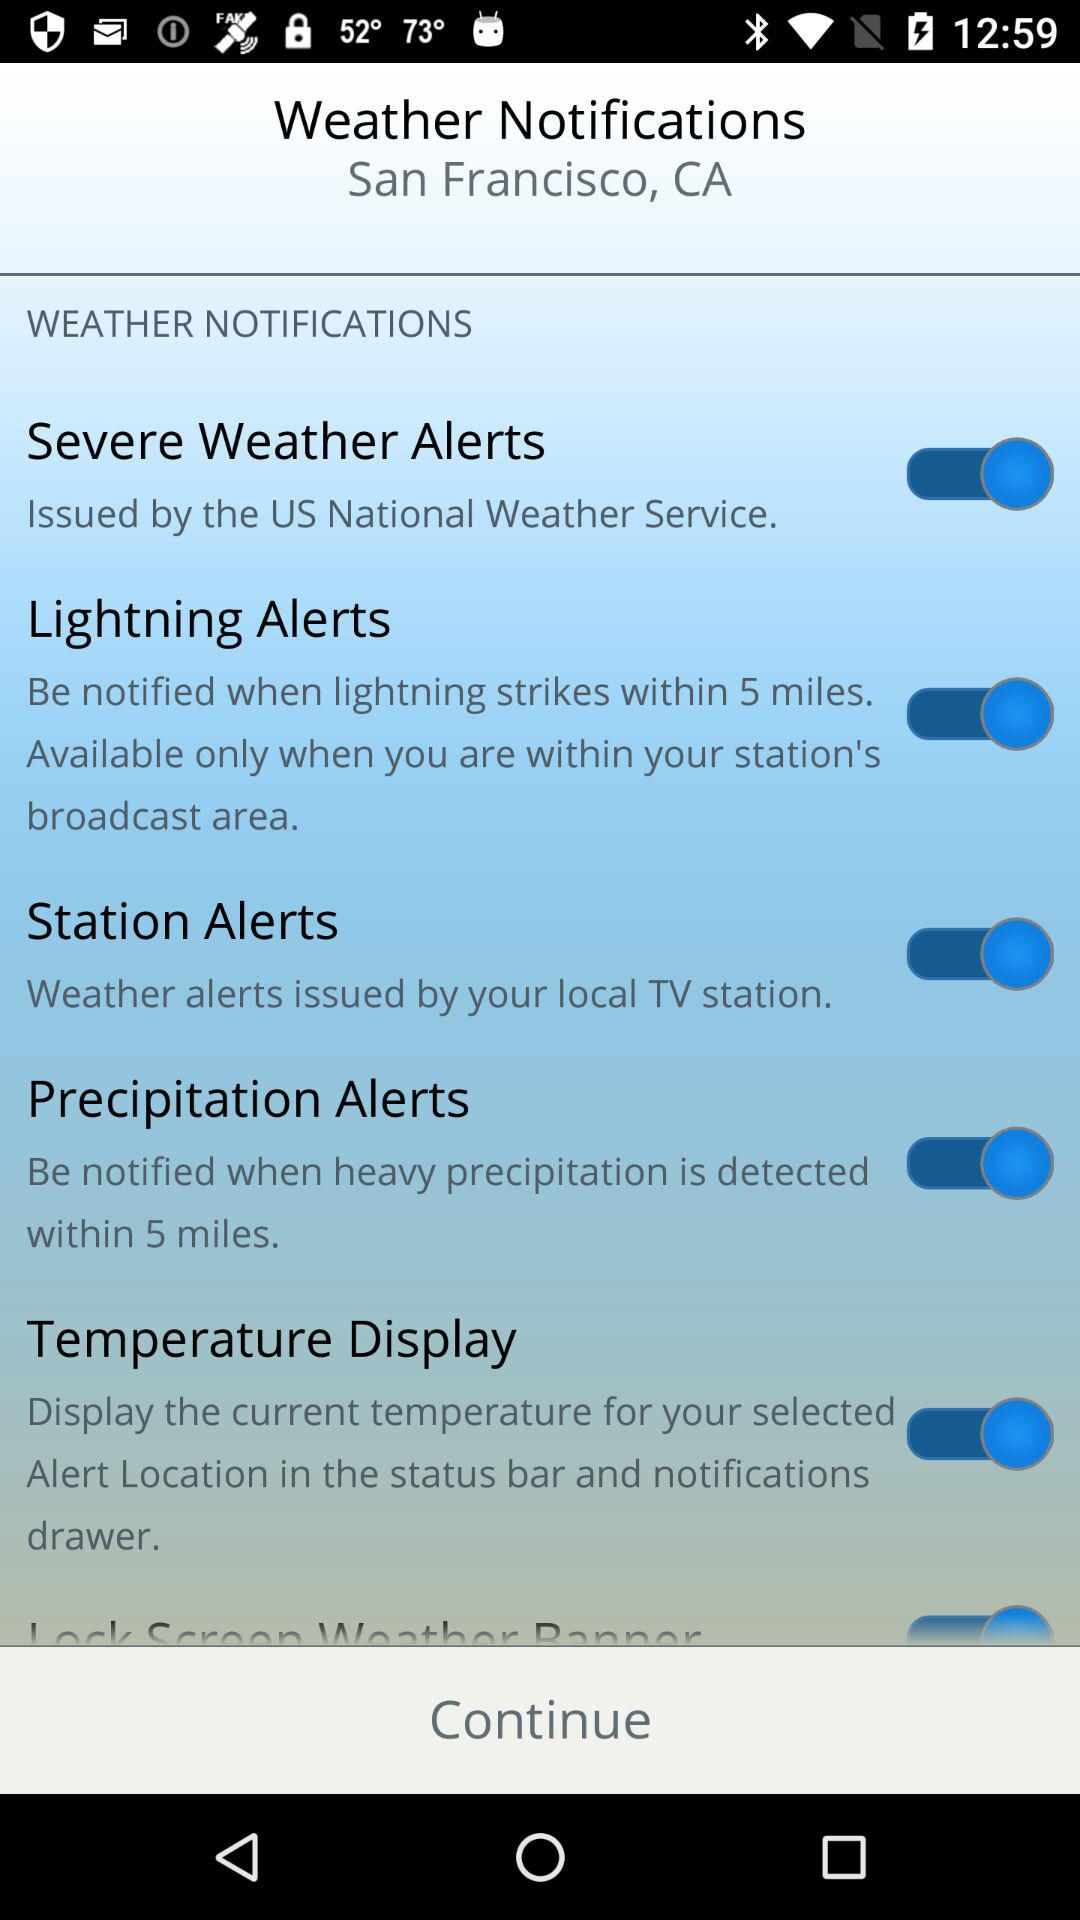What is the location? The location is San Francisco, CA. 